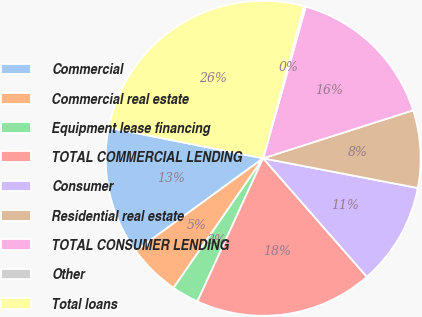Convert chart. <chart><loc_0><loc_0><loc_500><loc_500><pie_chart><fcel>Commercial<fcel>Commercial real estate<fcel>Equipment lease financing<fcel>TOTAL COMMERCIAL LENDING<fcel>Consumer<fcel>Residential real estate<fcel>TOTAL CONSUMER LENDING<fcel>Other<fcel>Total loans<nl><fcel>13.12%<fcel>5.37%<fcel>2.78%<fcel>18.29%<fcel>10.54%<fcel>7.95%<fcel>15.71%<fcel>0.19%<fcel>26.05%<nl></chart> 